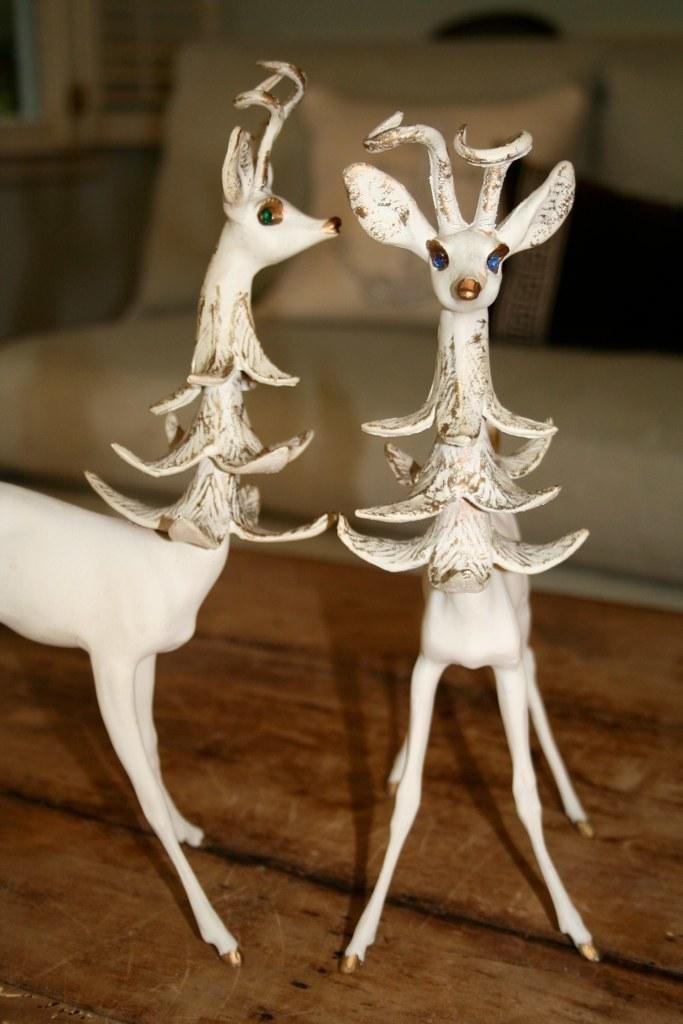What type of objects are on the table in the image? There are toys of animals on a table in the image. What type of furniture is present in the image? There is a sofa with pillows in the image. What can be seen in the background of the image? There is a window visible in the background. How many lizards are crawling through the hole in the image? There are no lizards or holes present in the image. What type of vehicle is parked outside the window in the image? There is no vehicle visible outside the window in the image. 